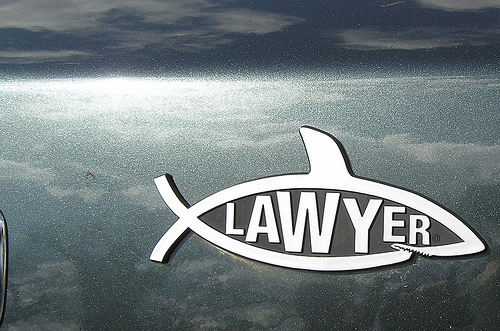<image>
Is there a vehicle in front of the metal shark? Yes. The vehicle is positioned in front of the metal shark, appearing closer to the camera viewpoint. 